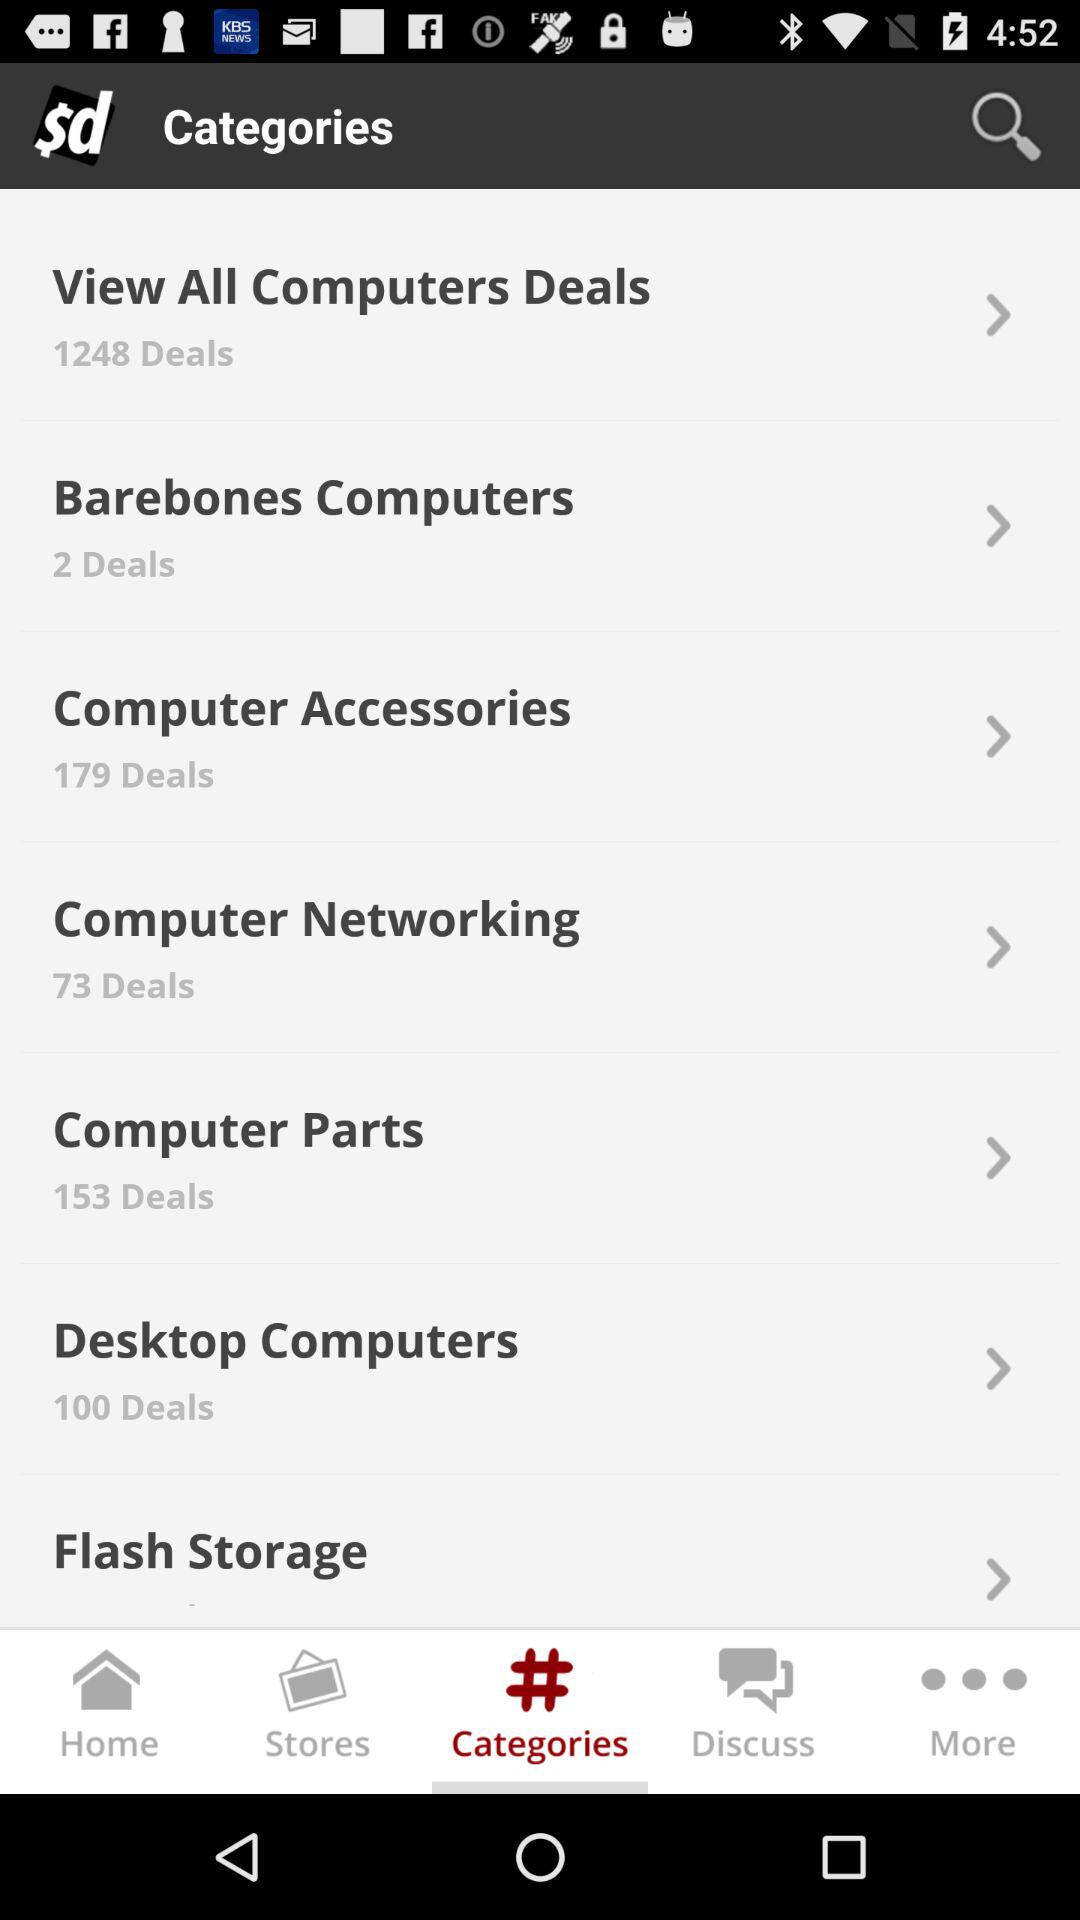How many deals are there in "Computer Networking"? There are 179 deals. 